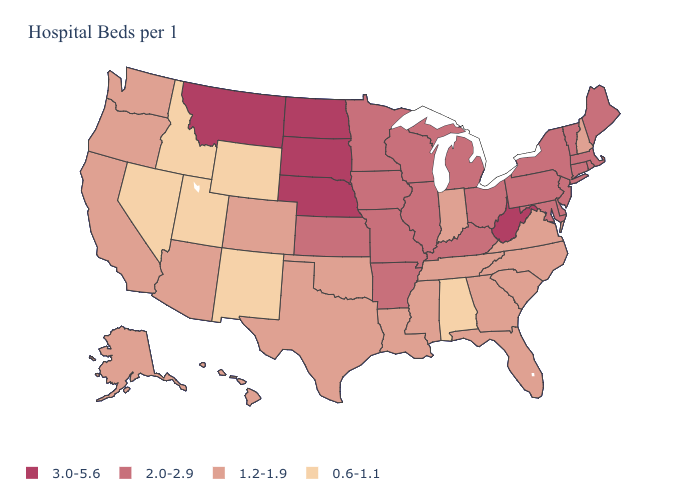Does the first symbol in the legend represent the smallest category?
Quick response, please. No. What is the highest value in states that border North Carolina?
Give a very brief answer. 1.2-1.9. Name the states that have a value in the range 1.2-1.9?
Concise answer only. Alaska, Arizona, California, Colorado, Florida, Georgia, Hawaii, Indiana, Louisiana, Mississippi, New Hampshire, North Carolina, Oklahoma, Oregon, South Carolina, Tennessee, Texas, Virginia, Washington. What is the value of Connecticut?
Short answer required. 2.0-2.9. What is the value of Florida?
Keep it brief. 1.2-1.9. Name the states that have a value in the range 0.6-1.1?
Keep it brief. Alabama, Idaho, Nevada, New Mexico, Utah, Wyoming. Does North Carolina have the same value as Alaska?
Keep it brief. Yes. What is the value of Alabama?
Give a very brief answer. 0.6-1.1. Does Mississippi have the highest value in the USA?
Write a very short answer. No. What is the highest value in states that border Virginia?
Concise answer only. 3.0-5.6. Name the states that have a value in the range 2.0-2.9?
Give a very brief answer. Arkansas, Connecticut, Delaware, Illinois, Iowa, Kansas, Kentucky, Maine, Maryland, Massachusetts, Michigan, Minnesota, Missouri, New Jersey, New York, Ohio, Pennsylvania, Rhode Island, Vermont, Wisconsin. Does Kentucky have a lower value than West Virginia?
Short answer required. Yes. Name the states that have a value in the range 1.2-1.9?
Short answer required. Alaska, Arizona, California, Colorado, Florida, Georgia, Hawaii, Indiana, Louisiana, Mississippi, New Hampshire, North Carolina, Oklahoma, Oregon, South Carolina, Tennessee, Texas, Virginia, Washington. Which states have the lowest value in the South?
Keep it brief. Alabama. Among the states that border Arkansas , which have the highest value?
Keep it brief. Missouri. 